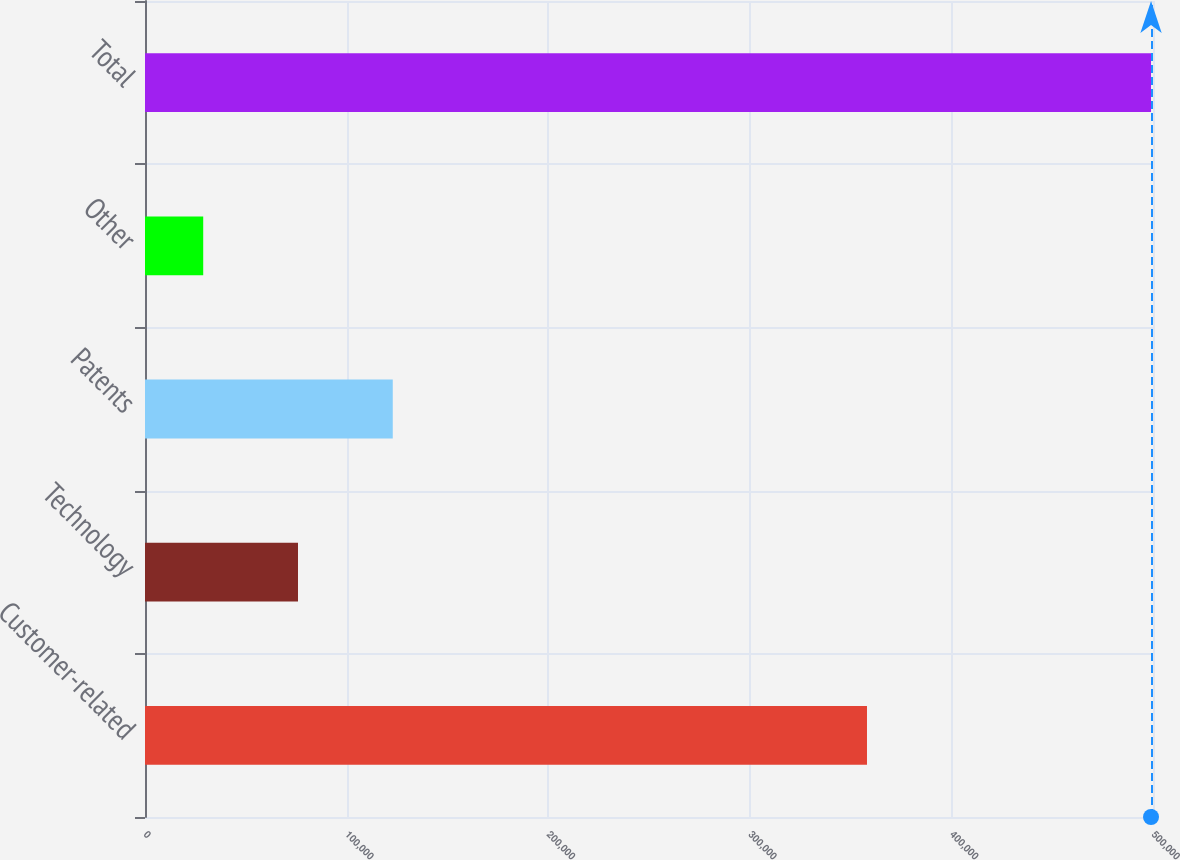<chart> <loc_0><loc_0><loc_500><loc_500><bar_chart><fcel>Customer-related<fcel>Technology<fcel>Patents<fcel>Other<fcel>Total<nl><fcel>358130<fcel>75889.8<fcel>122905<fcel>28875<fcel>499023<nl></chart> 